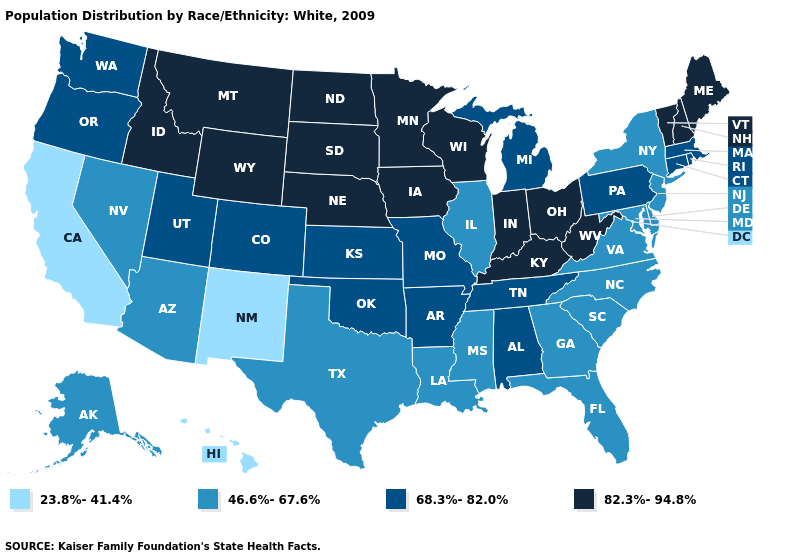Does New Mexico have the highest value in the West?
Concise answer only. No. Does Tennessee have a lower value than Indiana?
Short answer required. Yes. Does Hawaii have the same value as New Mexico?
Short answer required. Yes. Among the states that border Indiana , does Michigan have the lowest value?
Concise answer only. No. What is the highest value in the USA?
Keep it brief. 82.3%-94.8%. Name the states that have a value in the range 46.6%-67.6%?
Answer briefly. Alaska, Arizona, Delaware, Florida, Georgia, Illinois, Louisiana, Maryland, Mississippi, Nevada, New Jersey, New York, North Carolina, South Carolina, Texas, Virginia. What is the value of Iowa?
Quick response, please. 82.3%-94.8%. What is the value of Arizona?
Quick response, please. 46.6%-67.6%. What is the value of Maryland?
Short answer required. 46.6%-67.6%. What is the value of Arizona?
Short answer required. 46.6%-67.6%. What is the value of Nevada?
Write a very short answer. 46.6%-67.6%. Name the states that have a value in the range 23.8%-41.4%?
Answer briefly. California, Hawaii, New Mexico. Among the states that border Missouri , does Tennessee have the lowest value?
Write a very short answer. No. Which states have the lowest value in the West?
Answer briefly. California, Hawaii, New Mexico. 